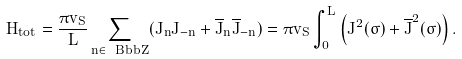<formula> <loc_0><loc_0><loc_500><loc_500>H _ { t o t } = \frac { \pi v _ { S } } { L } \sum _ { n \in \ B b b { Z } } ( J _ { n } J _ { - n } + \overline { J } _ { n } \overline { J } _ { - n } ) = \pi v _ { S } \int _ { 0 } ^ { L } \left ( { J } ^ { 2 } ( \sigma ) + \overline { J } ^ { 2 } ( \sigma ) \right ) .</formula> 